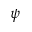<formula> <loc_0><loc_0><loc_500><loc_500>\psi</formula> 